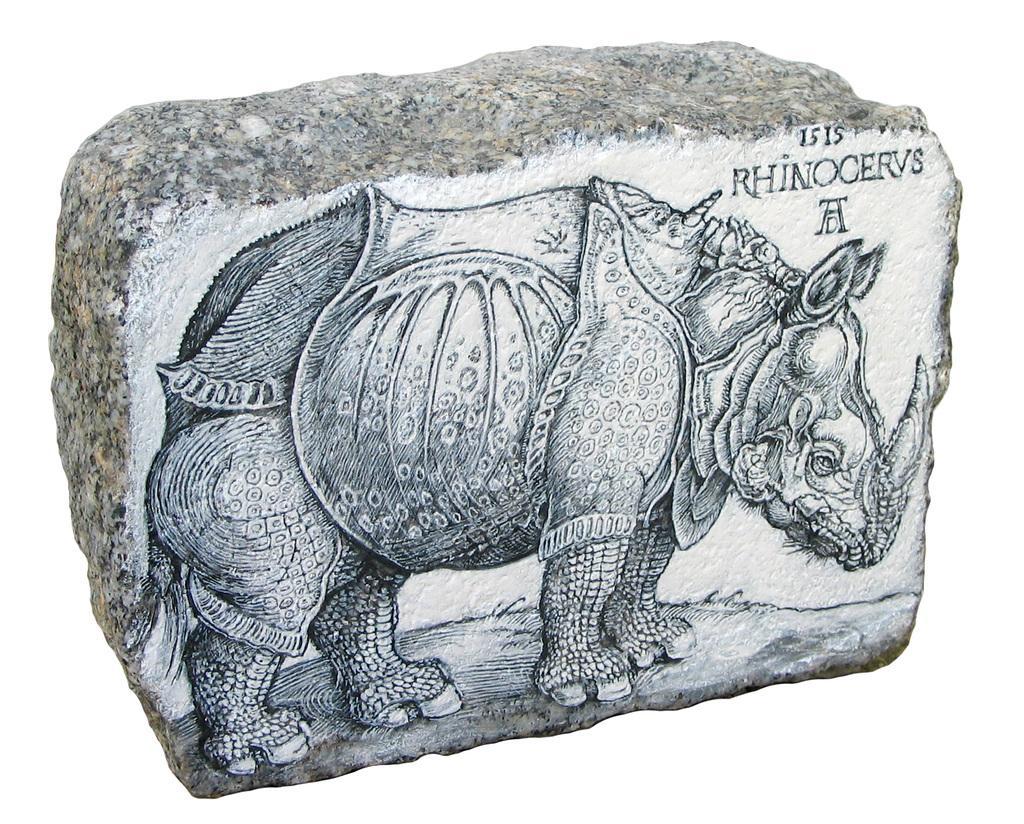In one or two sentences, can you explain what this image depicts? In this image we can see a rock. On the rock we can see the painting of an animal and text. The background of the image is white. 